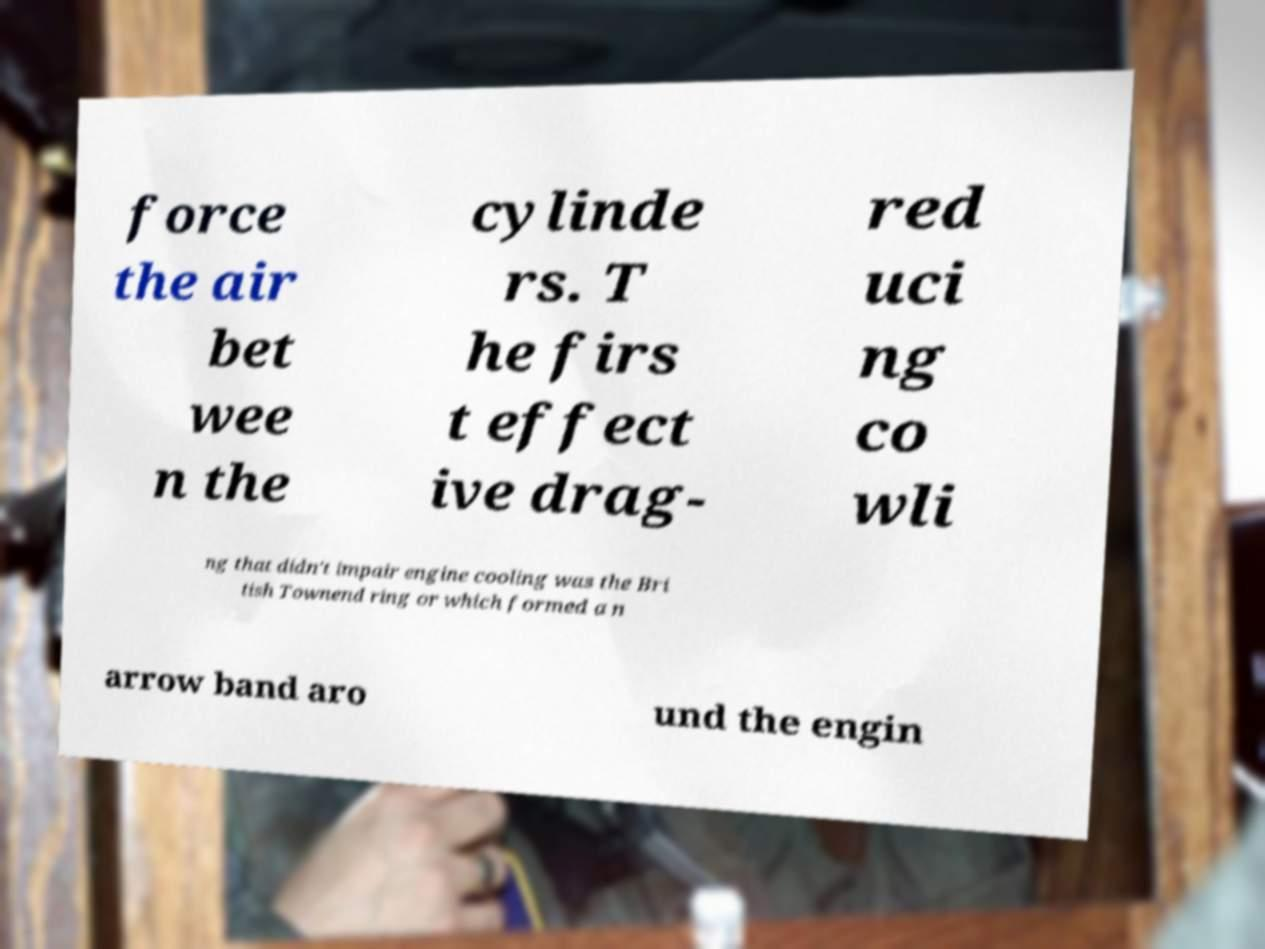There's text embedded in this image that I need extracted. Can you transcribe it verbatim? force the air bet wee n the cylinde rs. T he firs t effect ive drag- red uci ng co wli ng that didn't impair engine cooling was the Bri tish Townend ring or which formed a n arrow band aro und the engin 